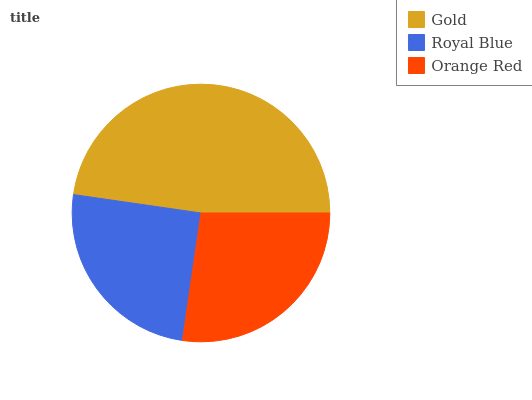Is Royal Blue the minimum?
Answer yes or no. Yes. Is Gold the maximum?
Answer yes or no. Yes. Is Orange Red the minimum?
Answer yes or no. No. Is Orange Red the maximum?
Answer yes or no. No. Is Orange Red greater than Royal Blue?
Answer yes or no. Yes. Is Royal Blue less than Orange Red?
Answer yes or no. Yes. Is Royal Blue greater than Orange Red?
Answer yes or no. No. Is Orange Red less than Royal Blue?
Answer yes or no. No. Is Orange Red the high median?
Answer yes or no. Yes. Is Orange Red the low median?
Answer yes or no. Yes. Is Royal Blue the high median?
Answer yes or no. No. Is Royal Blue the low median?
Answer yes or no. No. 